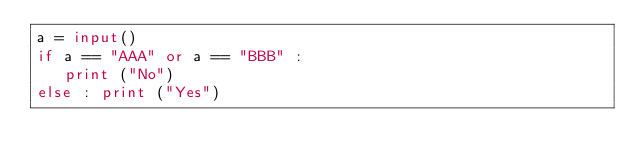<code> <loc_0><loc_0><loc_500><loc_500><_Python_>a = input()
if a == "AAA" or a == "BBB" :
	 print ("No")
else : print ("Yes")
</code> 